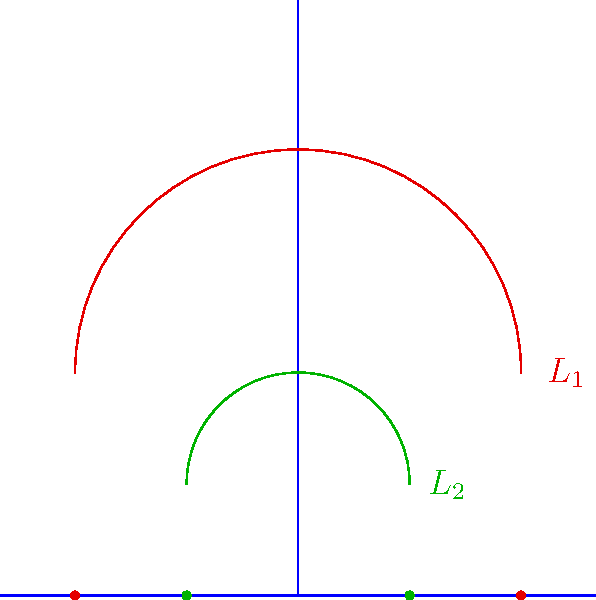In the upper half-plane model of hyperbolic geometry, two lines $L_1$ and $L_2$ are shown. Given that these lines are parallel in hyperbolic space, what can be concluded about their relationship in Euclidean space? How does this representation challenge our conventional understanding of parallel lines? To understand this question, let's consider the following steps:

1) In the upper half-plane model of hyperbolic geometry, lines are represented by either vertical Euclidean lines or Euclidean semicircles with centers on the x-axis.

2) In this model, two lines are parallel if they do not intersect in the upper half-plane.

3) Looking at the diagram, we see two semicircles $L_1$ and $L_2$. These semicircles do not intersect in the upper half-plane, which means they are parallel in hyperbolic space.

4) However, in Euclidean space, these semicircles clearly intersect at two points on the x-axis. This is a key difference between Euclidean and hyperbolic geometry.

5) In Euclidean geometry, parallel lines maintain a constant distance from each other and never intersect. In hyperbolic geometry, parallel lines can appear to "diverge" from each other.

6) This representation challenges our conventional understanding of parallel lines because:
   a) These parallel lines (in hyperbolic space) intersect when viewed in Euclidean space.
   b) The distance between these parallel lines is not constant; it increases as we move away from the x-axis.

7) This illustrates a fundamental property of hyperbolic geometry: through a point not on a given line, there exist multiple lines parallel to the given line. This contrasts with Euclidean geometry's parallel postulate.

In conclusion, this representation shows that parallel lines in hyperbolic geometry can intersect when viewed in Euclidean space, demonstrating the profound differences between these two geometrical systems.
Answer: Parallel lines in hyperbolic space can intersect in Euclidean space, challenging the Euclidean notion of parallel lines never meeting. 